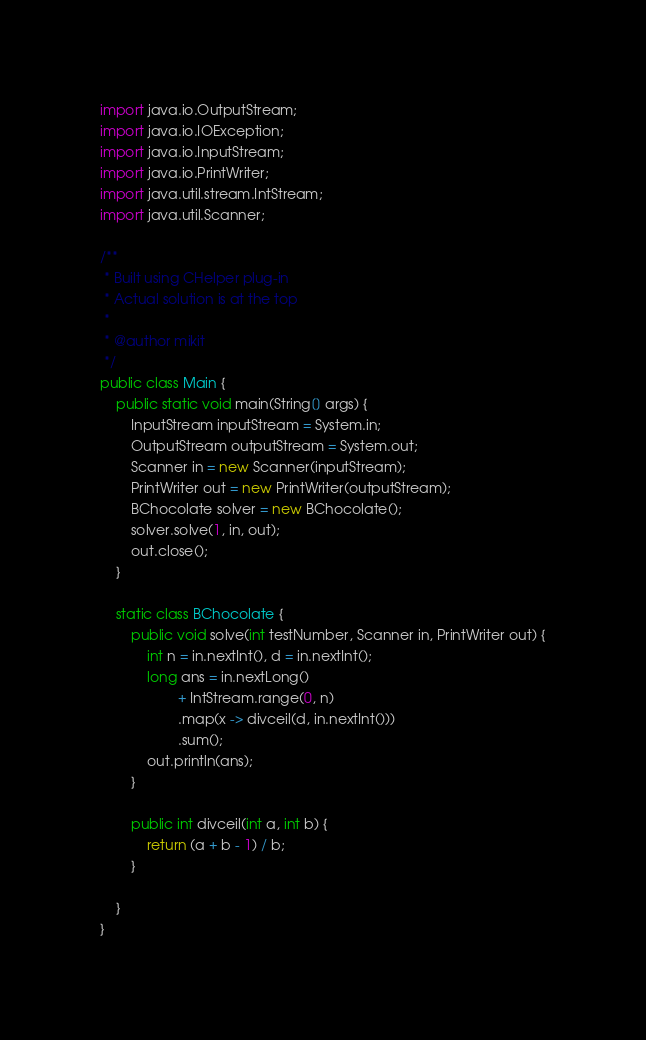<code> <loc_0><loc_0><loc_500><loc_500><_Java_>import java.io.OutputStream;
import java.io.IOException;
import java.io.InputStream;
import java.io.PrintWriter;
import java.util.stream.IntStream;
import java.util.Scanner;

/**
 * Built using CHelper plug-in
 * Actual solution is at the top
 *
 * @author mikit
 */
public class Main {
    public static void main(String[] args) {
        InputStream inputStream = System.in;
        OutputStream outputStream = System.out;
        Scanner in = new Scanner(inputStream);
        PrintWriter out = new PrintWriter(outputStream);
        BChocolate solver = new BChocolate();
        solver.solve(1, in, out);
        out.close();
    }

    static class BChocolate {
        public void solve(int testNumber, Scanner in, PrintWriter out) {
            int n = in.nextInt(), d = in.nextInt();
            long ans = in.nextLong()
                    + IntStream.range(0, n)
                    .map(x -> divceil(d, in.nextInt()))
                    .sum();
            out.println(ans);
        }

        public int divceil(int a, int b) {
            return (a + b - 1) / b;
        }

    }
}

</code> 